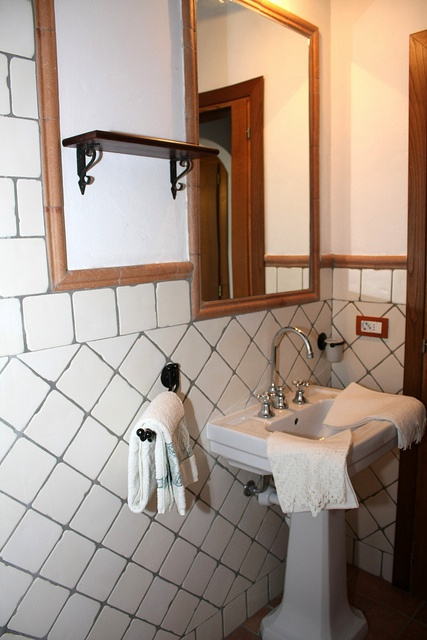Describe the objects in this image and their specific colors. I can see sink in darkgray, tan, and gray tones and cup in darkgray, gray, black, and brown tones in this image. 